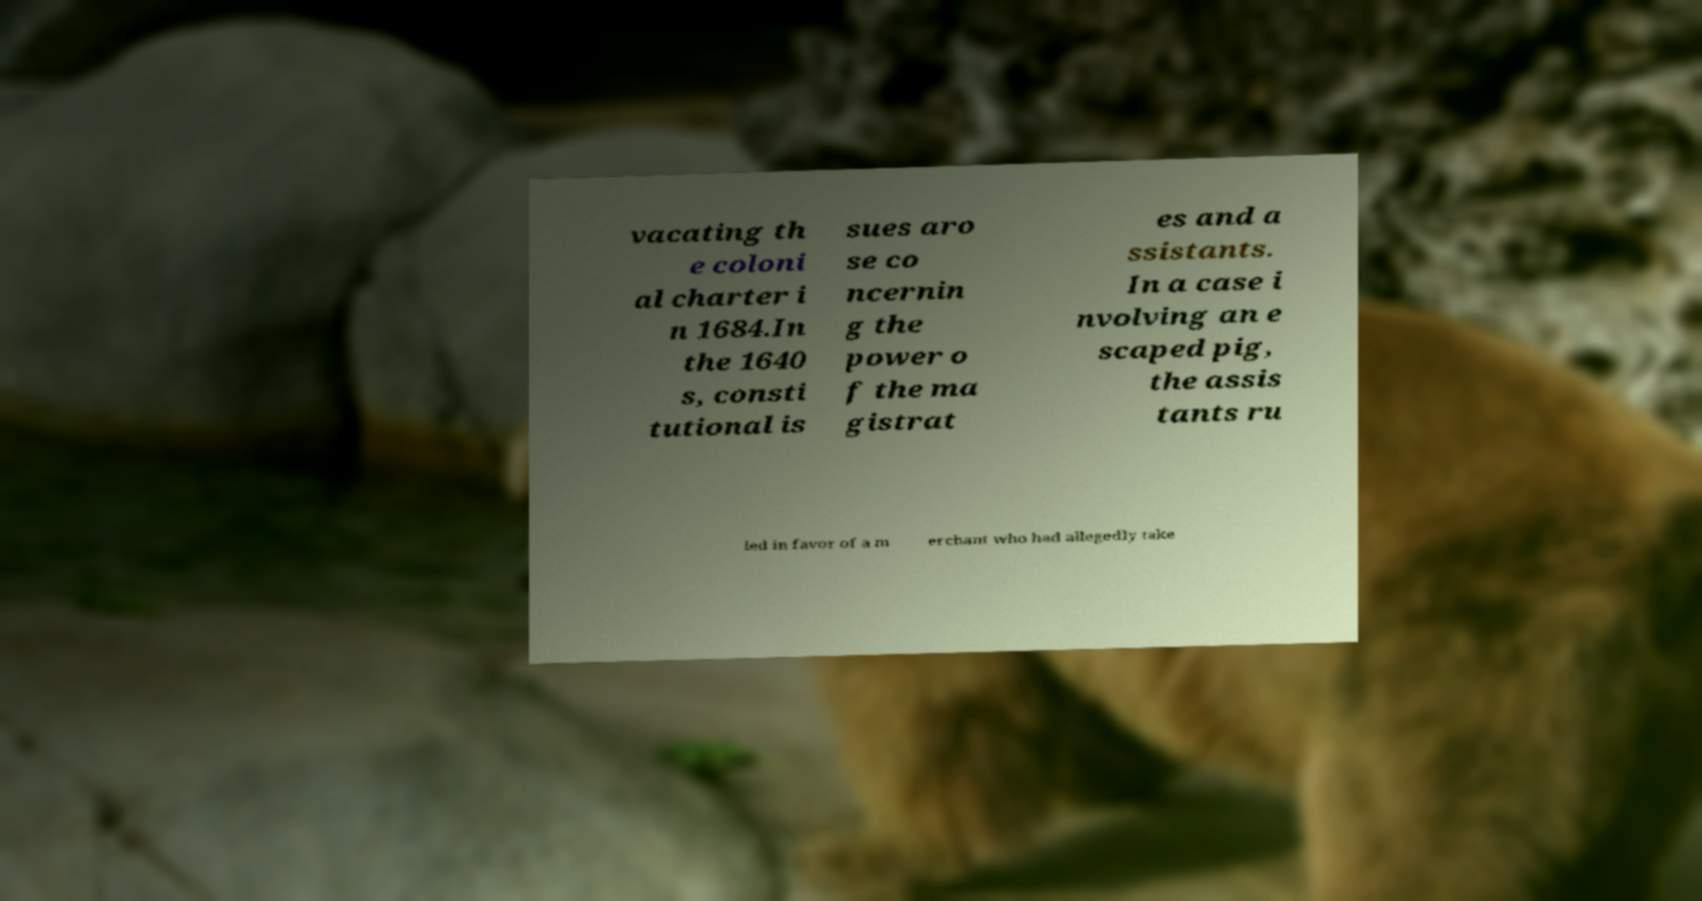Please identify and transcribe the text found in this image. vacating th e coloni al charter i n 1684.In the 1640 s, consti tutional is sues aro se co ncernin g the power o f the ma gistrat es and a ssistants. In a case i nvolving an e scaped pig, the assis tants ru led in favor of a m erchant who had allegedly take 